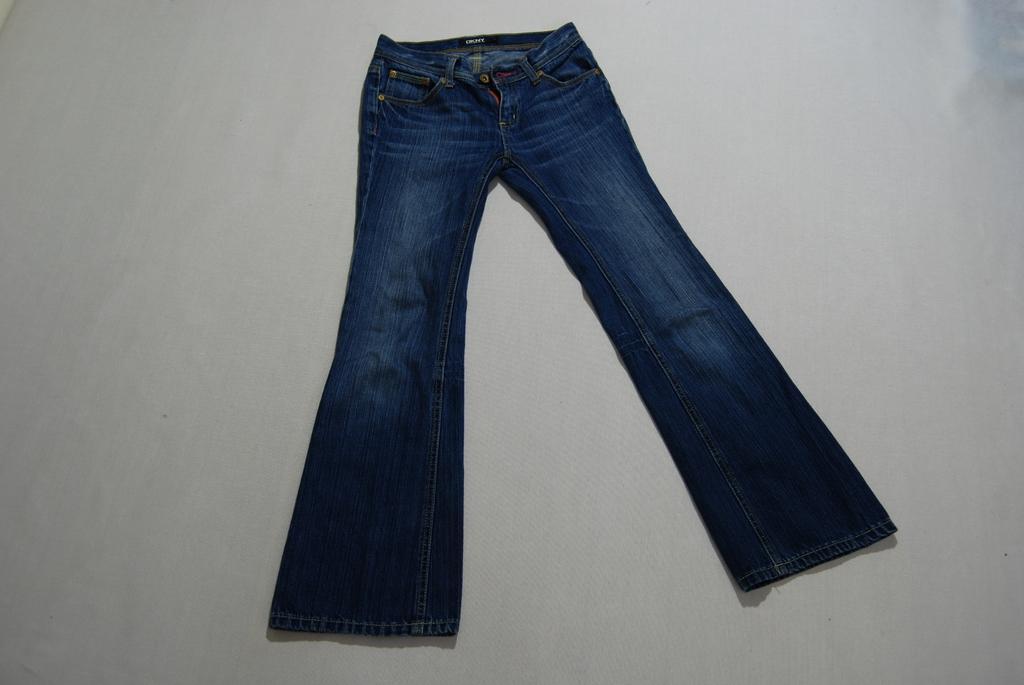Could you give a brief overview of what you see in this image? In this image we can see the jean on the plain surface. 